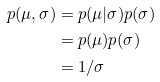Convert formula to latex. <formula><loc_0><loc_0><loc_500><loc_500>p ( \mu , \sigma ) & = p ( \mu | \sigma ) p ( \sigma ) \\ & = p ( \mu ) p ( \sigma ) \\ & = 1 / \sigma</formula> 